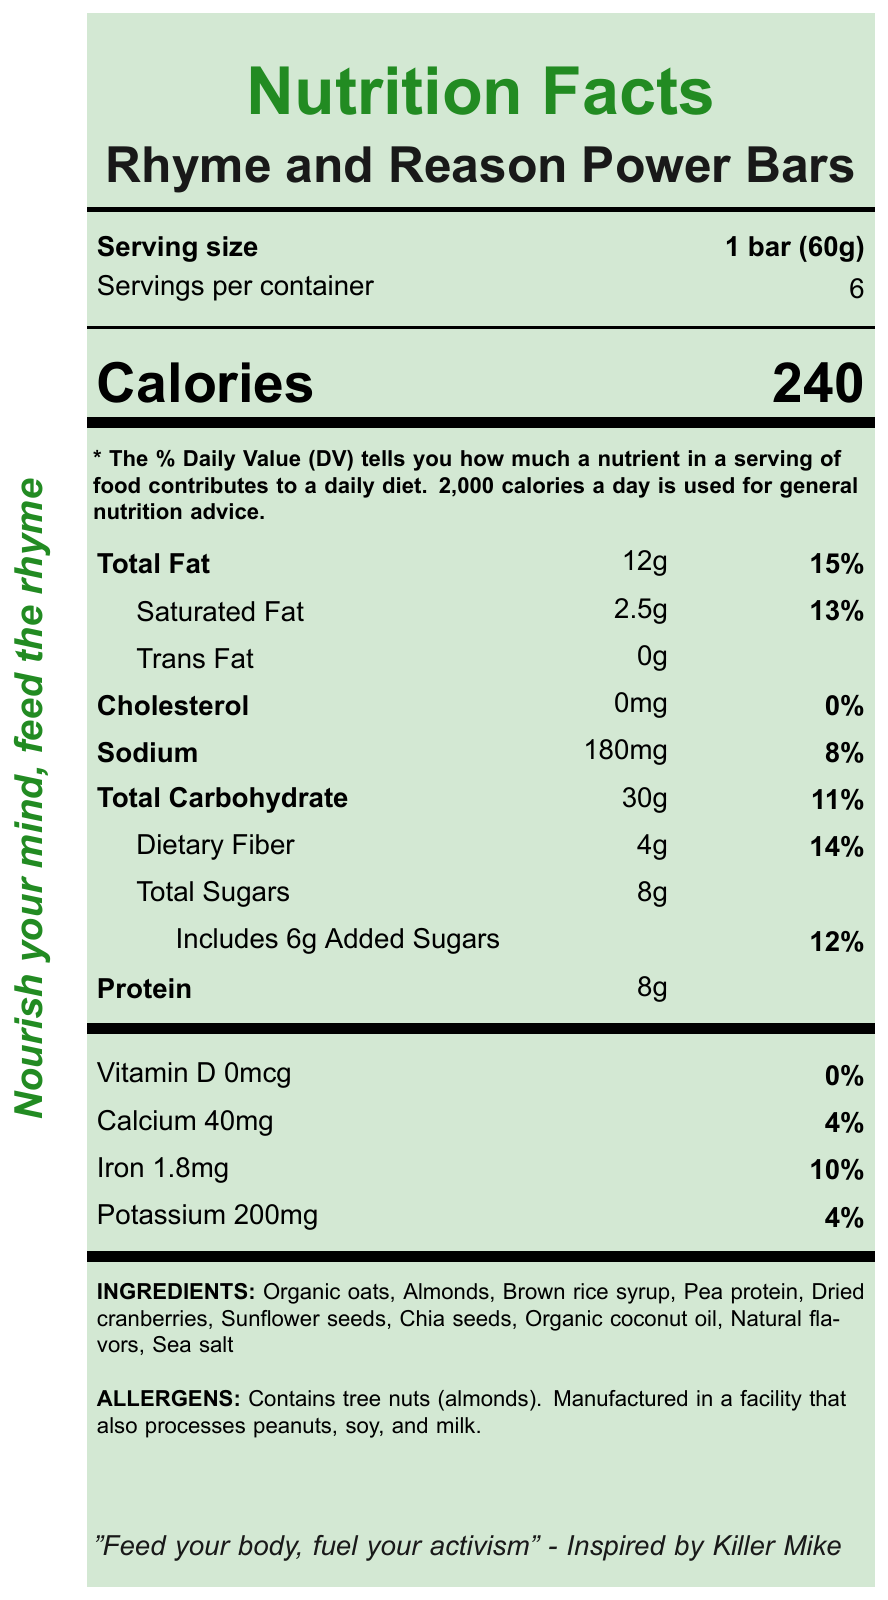what is the serving size for the Rhyme and Reason Power Bars? The serving size is mentioned right under the product name "Rhyme and Reason Power Bars" with the label "Serving size".
Answer: 1 bar (60g) how many calories are in one serving of the Power Bars? The number of calories in one serving is listed right below the "Calories" heading.
Answer: 240 list all ingredients in the Power Bars The ingredients are listed under the section labeled "INGREDIENTS" towards the bottom of the document.
Answer: Organic oats, Almonds, Brown rice syrup, Pea protein, Dried cranberries, Sunflower seeds, Chia seeds, Organic coconut oil, Natural flavors, Sea salt what is the daily value percentage for dietary fiber? The daily value percentage for dietary fiber is listed under "Dietary Fiber" in the nutrients table as 14%.
Answer: 14% how many servings are there per container? The number of servings per container is listed under the "Servings per container" heading.
Answer: 6 which of the following contains the highest daily value percentage? A. Total Fat B. Sodium C. Iron D. Potassium Total Fat has a daily value of 15%, which is greater than Sodium (8%), Iron (10%), and Potassium (4%).
Answer: A. Total Fat how much protein is in one serving? A. 4g B. 6g C. 8g D. 10g The amount of protein per serving is listed as 8g in the nutrients section.
Answer: C. 8g does the product contain any cholesterol? The cholesterol content is listed as 0mg, with a daily value percentage of 0%.
Answer: No summarize the main idea of the document The document lists detailed nutritional information, ingredients, and political activist-themed slogans and quotes, designed to appeal to fans of political rap and hip-hop music.
Answer: The document provides nutrition facts for Rhyme and Reason Power Bars, highlighting serving size, calories, macronutrients, and micronutrients along with their daily values. It emphasizes ingredients, allergen information, and includes slogans and quotes inspired by political hip-hop artists. who is the quote "Feed your body, fuel your activism" inspired by? The quote "Feed your body, fuel your activism" is listed in the document and is inspired by Killer Mike.
Answer: Killer Mike what is the amount of sodium in each bar in milligrams? The amount of sodium per serving is specified in milligrams (mg) in the nutrients section as 180mg.
Answer: 180mg what are the activist themes associated with the snack? The activist themes are listed in the document as "Freedom of Speech", "Social Justice", and "Equality".
Answer: Freedom of Speech, Social Justice, Equality how much of the total carbohydrate is dietary fiber? The total carbohydrate amount is 30g, out of which 4g is listed as dietary fiber.
Answer: 4g what is the purpose of the slogans and quotes in the document? The document includes slogans and quotes, but it does not explicitly state their purpose. The reader can infer their motivational or promotional nature, but this is not clearly addressed in the document itself.
Answer: Cannot be determined 